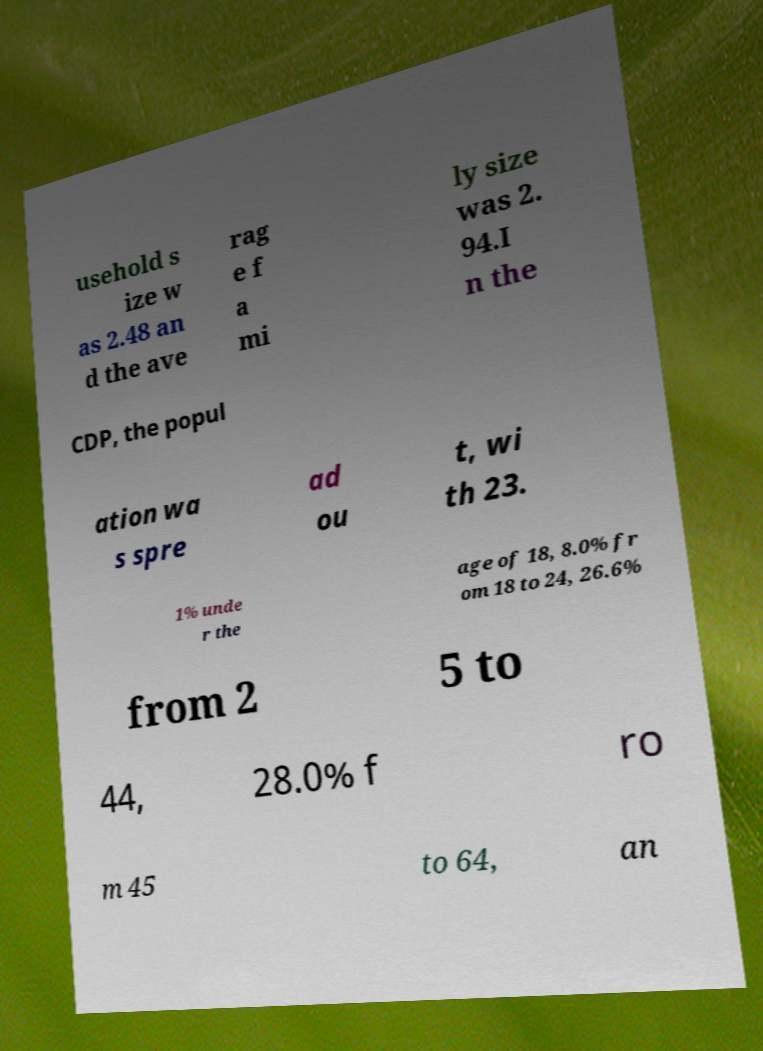What messages or text are displayed in this image? I need them in a readable, typed format. usehold s ize w as 2.48 an d the ave rag e f a mi ly size was 2. 94.I n the CDP, the popul ation wa s spre ad ou t, wi th 23. 1% unde r the age of 18, 8.0% fr om 18 to 24, 26.6% from 2 5 to 44, 28.0% f ro m 45 to 64, an 